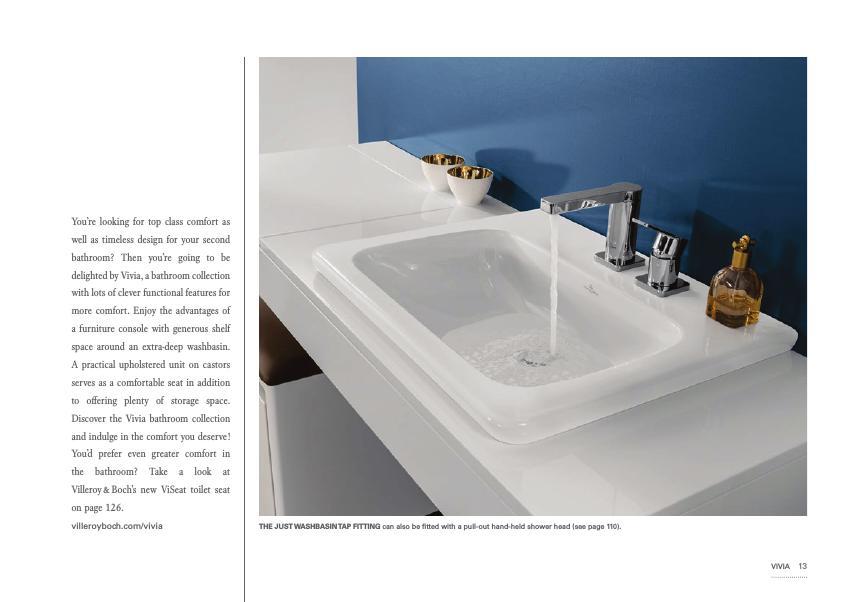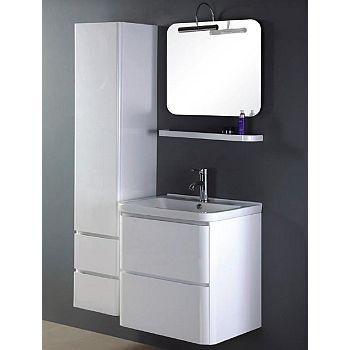The first image is the image on the left, the second image is the image on the right. Examine the images to the left and right. Is the description "There are three faucets." accurate? Answer yes or no. No. The first image is the image on the left, the second image is the image on the right. Given the left and right images, does the statement "Three faucets are visible." hold true? Answer yes or no. No. 